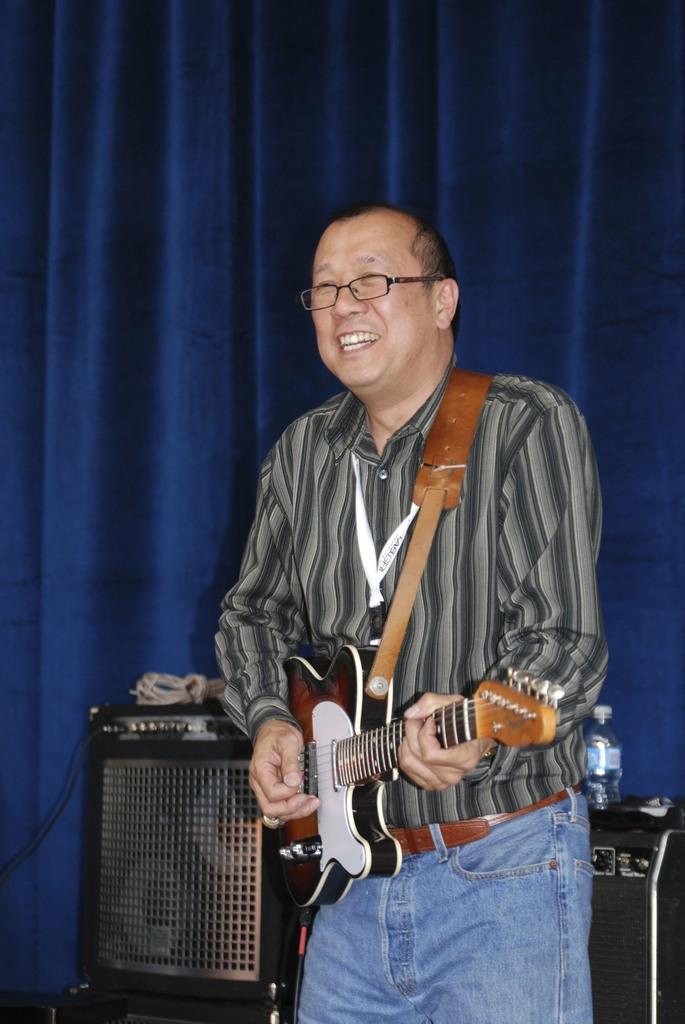What is the main subject of the image? There is a person in the image. What is the person holding in the image? The person is holding a guitar. What can be seen in the background of the image? There is a blue curtain in the background of the image. How many feet can be seen in the image? There is no mention of feet in the image, as it primarily focuses on the person holding a guitar. 